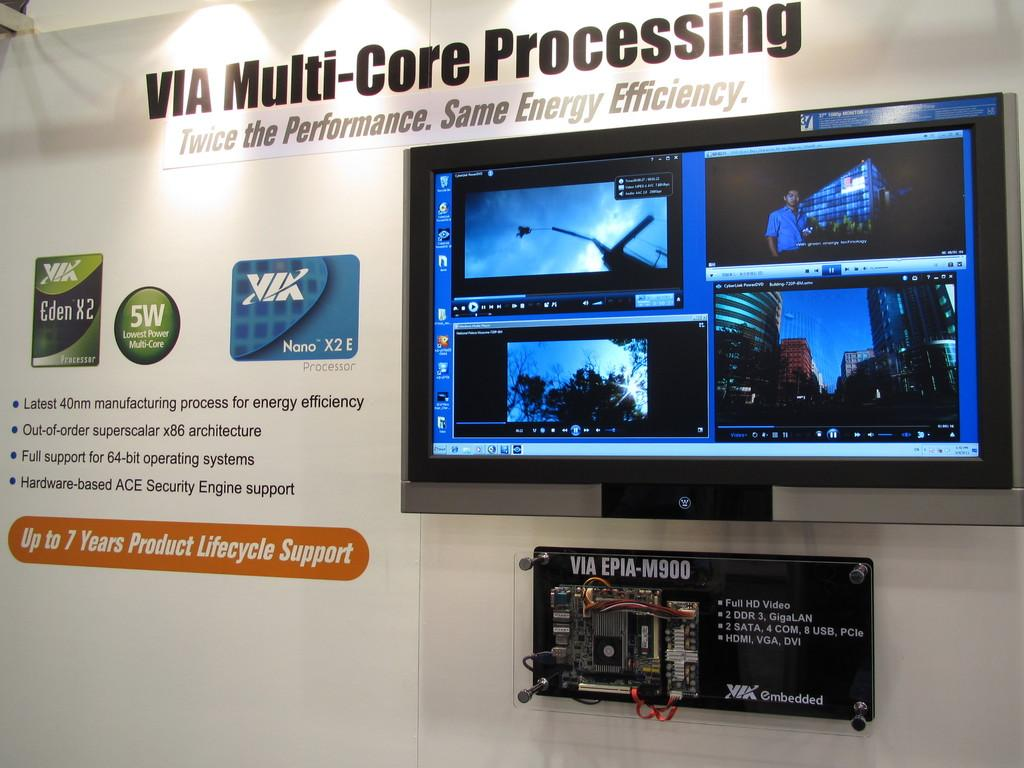<image>
Create a compact narrative representing the image presented. A  sign promoting VIA Multi-Core Processing includes a monitor with various images displaying. 